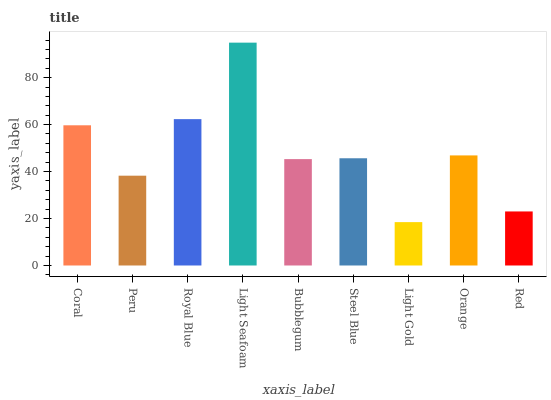Is Light Gold the minimum?
Answer yes or no. Yes. Is Light Seafoam the maximum?
Answer yes or no. Yes. Is Peru the minimum?
Answer yes or no. No. Is Peru the maximum?
Answer yes or no. No. Is Coral greater than Peru?
Answer yes or no. Yes. Is Peru less than Coral?
Answer yes or no. Yes. Is Peru greater than Coral?
Answer yes or no. No. Is Coral less than Peru?
Answer yes or no. No. Is Steel Blue the high median?
Answer yes or no. Yes. Is Steel Blue the low median?
Answer yes or no. Yes. Is Coral the high median?
Answer yes or no. No. Is Light Gold the low median?
Answer yes or no. No. 